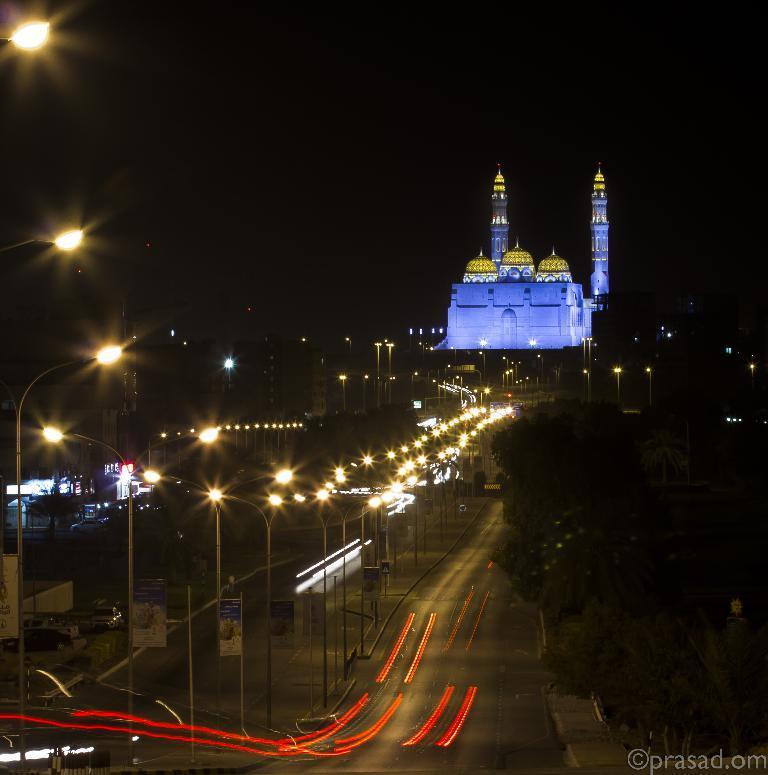How would you summarize this image in a sentence or two? In this picture, there are lamp poles, vehicles and posters in the foreground area of the image, it seems like building and the picture is captured during night time. 